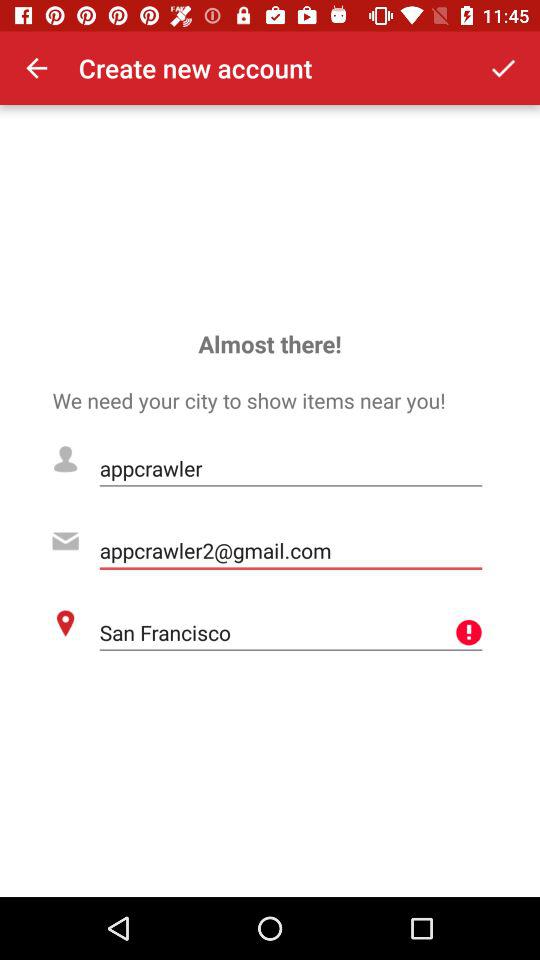What is the email address? The email address is appcrawler2@gmail.com. 